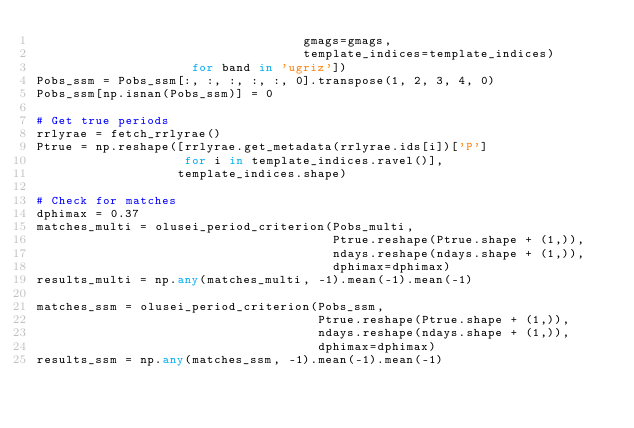<code> <loc_0><loc_0><loc_500><loc_500><_Python_>                                    gmags=gmags,
                                    template_indices=template_indices)
                     for band in 'ugriz'])
Pobs_ssm = Pobs_ssm[:, :, :, :, :, 0].transpose(1, 2, 3, 4, 0)
Pobs_ssm[np.isnan(Pobs_ssm)] = 0

# Get true periods
rrlyrae = fetch_rrlyrae()
Ptrue = np.reshape([rrlyrae.get_metadata(rrlyrae.ids[i])['P']
                    for i in template_indices.ravel()],
                   template_indices.shape)

# Check for matches
dphimax = 0.37
matches_multi = olusei_period_criterion(Pobs_multi,
                                        Ptrue.reshape(Ptrue.shape + (1,)),
                                        ndays.reshape(ndays.shape + (1,)),
                                        dphimax=dphimax)
results_multi = np.any(matches_multi, -1).mean(-1).mean(-1)

matches_ssm = olusei_period_criterion(Pobs_ssm,
                                      Ptrue.reshape(Ptrue.shape + (1,)),
                                      ndays.reshape(ndays.shape + (1,)),
                                      dphimax=dphimax)
results_ssm = np.any(matches_ssm, -1).mean(-1).mean(-1)
</code> 